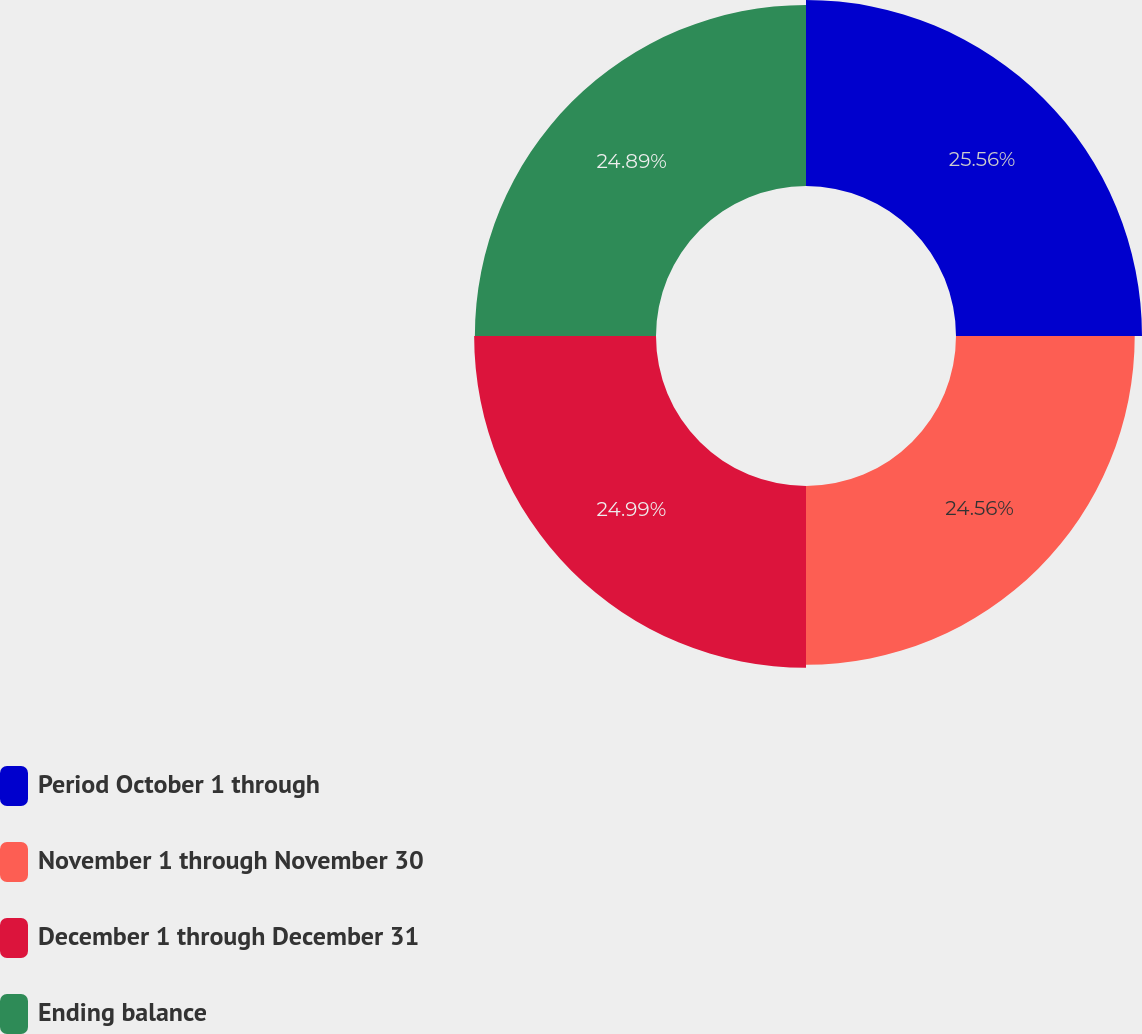Convert chart to OTSL. <chart><loc_0><loc_0><loc_500><loc_500><pie_chart><fcel>Period October 1 through<fcel>November 1 through November 30<fcel>December 1 through December 31<fcel>Ending balance<nl><fcel>25.56%<fcel>24.56%<fcel>24.99%<fcel>24.89%<nl></chart> 